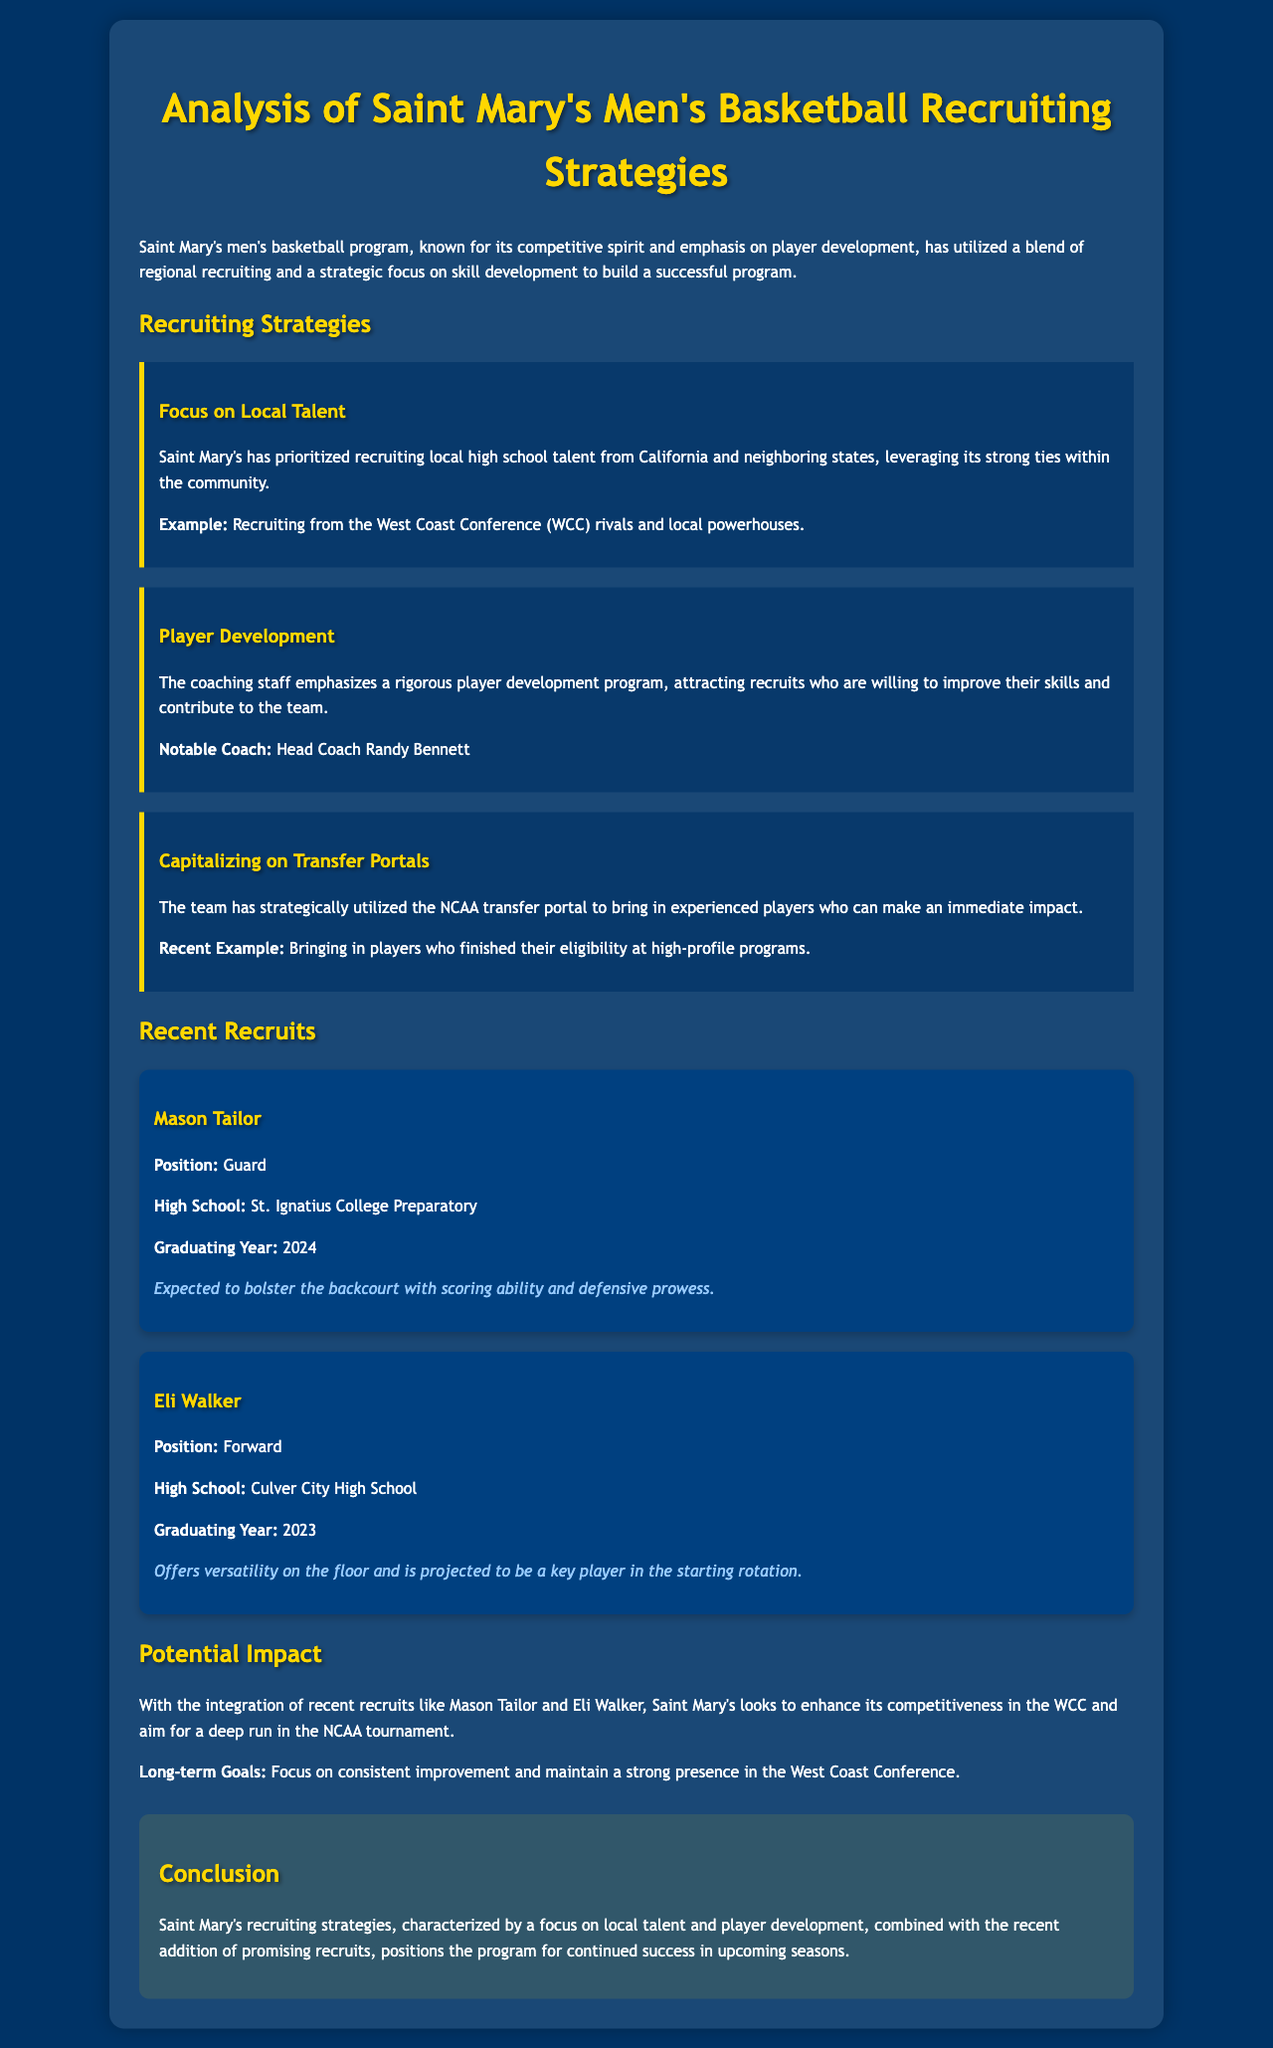What local talent does Saint Mary's prioritize? The document states that Saint Mary's has prioritized recruiting local high school talent from California and neighboring states.
Answer: Local high school talent Who is the head coach of Saint Mary's men's basketball? The document mentions Head Coach Randy Bennett as notable in the player development section.
Answer: Randy Bennett What position does Mason Tailor play? The document specifies that Mason Tailor plays the guard position.
Answer: Guard When is Eli Walker's graduating year? The document indicates that Eli Walker is graduating in 2023.
Answer: 2023 What impact is Mason Tailor expected to have? The document states that Mason Tailor is expected to bolster the backcourt with scoring ability and defensive prowess.
Answer: Bolster the backcourt Which strategy involves bringing in experienced players? The document explains that the team has strategically utilized the NCAA transfer portal for experienced players.
Answer: Transfer portals What is a long-term goal for Saint Mary's men's basketball? The document lists a focus on consistent improvement and maintaining a strong presence in the West Coast Conference as long-term goals.
Answer: Consistent improvement How does Saint Mary's men's basketball aim to enhance competitiveness? The document mentions the integration of recent recruits like Mason Tailor and Eli Walker as a means to enhance competitiveness in the WCC.
Answer: Recent recruits What is the background color of the document? The document’s style settings describe the background color of the body as dark blue (#003366).
Answer: Dark blue 